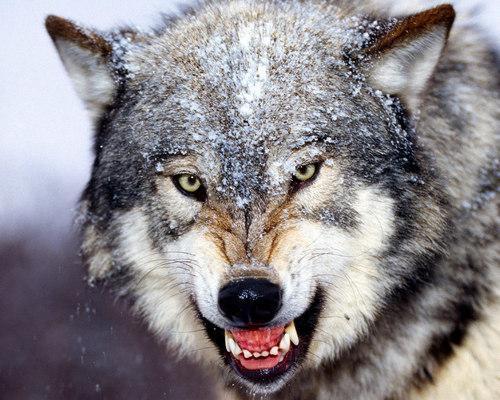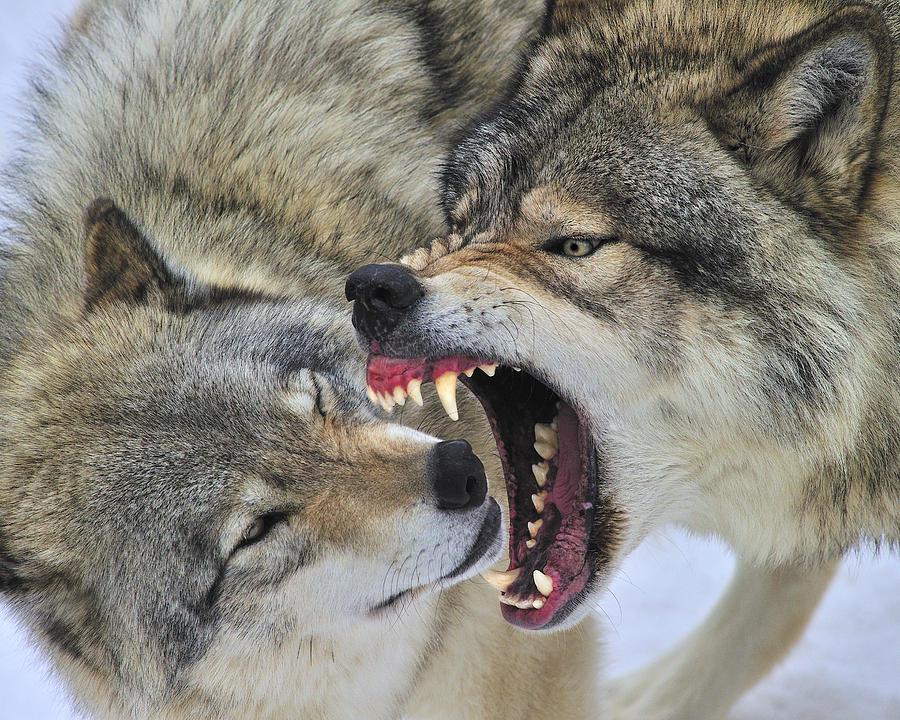The first image is the image on the left, the second image is the image on the right. Evaluate the accuracy of this statement regarding the images: "Only the head of the animal is visible in the image on the left.". Is it true? Answer yes or no. Yes. 